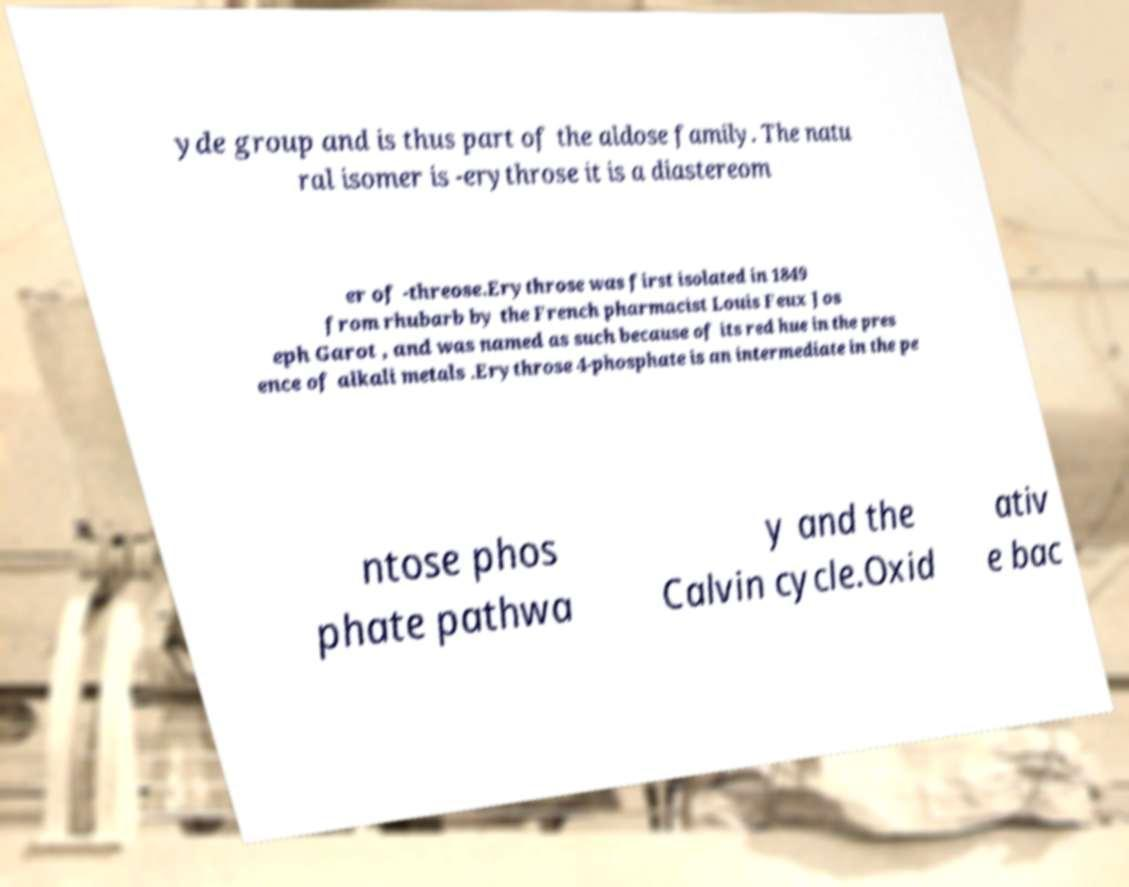Could you extract and type out the text from this image? yde group and is thus part of the aldose family. The natu ral isomer is -erythrose it is a diastereom er of -threose.Erythrose was first isolated in 1849 from rhubarb by the French pharmacist Louis Feux Jos eph Garot , and was named as such because of its red hue in the pres ence of alkali metals .Erythrose 4-phosphate is an intermediate in the pe ntose phos phate pathwa y and the Calvin cycle.Oxid ativ e bac 